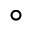<formula> <loc_0><loc_0><loc_500><loc_500>^ { \circ }</formula> 